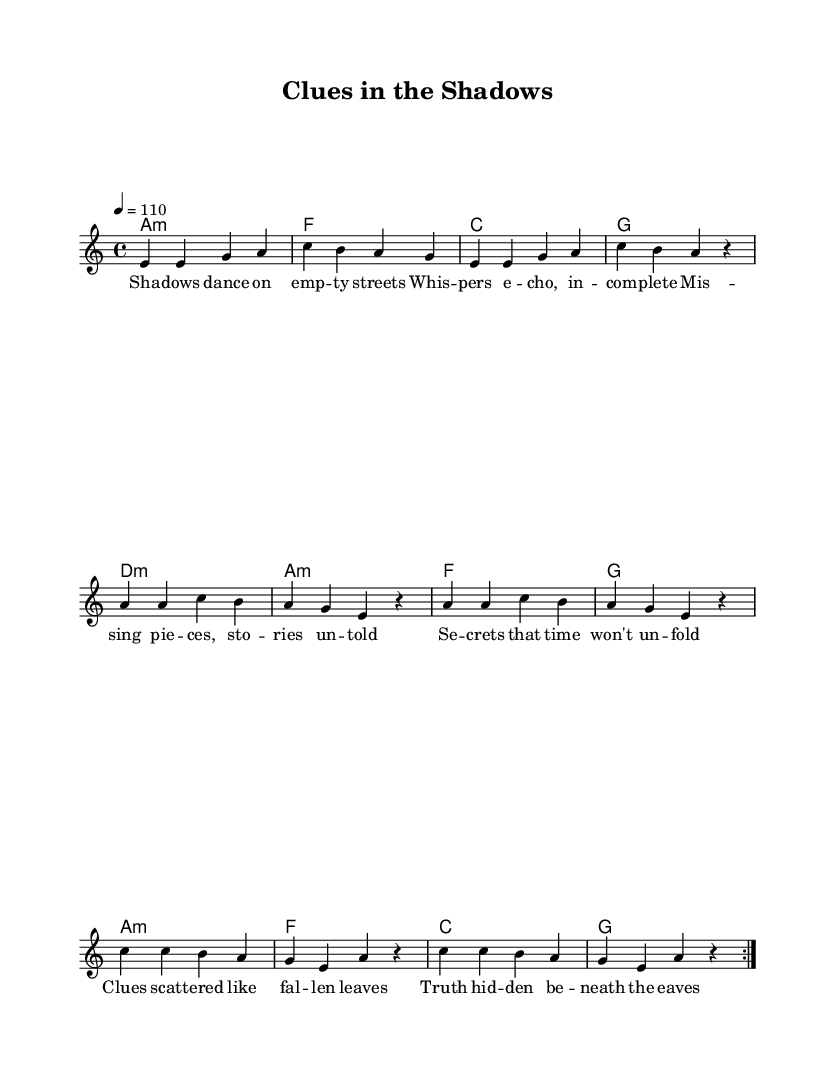What is the key signature of this music? The key signature is A minor, which has no sharps or flats. A minor is the relative minor of C major, indicating the lack of accidentals.
Answer: A minor What is the time signature of this music? The time signature is 4/4, which means there are four beats per measure, and the quarter note gets one beat. This is indicated at the beginning of the sheet music.
Answer: 4/4 What is the tempo marking for this piece? The tempo marking is quarter note equals 110 beats per minute, indicated by "4 = 110" at the beginning of the score. This tells performers how fast to play.
Answer: 110 How many times is the melody repeated? The melody is repeated 2 times, as indicated by the "repeat volta 2" instruction before the first section of the melody. This shows that the section will be played twice before moving on.
Answer: 2 What is the lyrical theme of the song? The lyrical theme revolves around unsolved mysteries and hidden truths, conveying a sense of intrigue and discovery in the lyrics presented in the verse and chorus. This theme is highlighted in phrases such as "chasing clues in the shadows" and "missing pieces."
Answer: Unsolved mysteries What type of chords are predominantly used in this piece? The piece primarily uses minor and major chords, specifically indicated as "m" for minor chords (A minor, D minor) and regular name chords for major (C, F, G). These chord types often create a soulful and expressive sound typical in Rhythm and Blues.
Answer: Minor and major chords What is the overall structure of the song? The overall structure consists of a verse, pre-chorus, and chorus, typical in songwriting, where the verse sets up the narrative, the pre-chorus builds up, and the chorus delivers the main message of the song. This structure helps in creating memorable hooks.
Answer: Verse, pre-chorus, chorus 